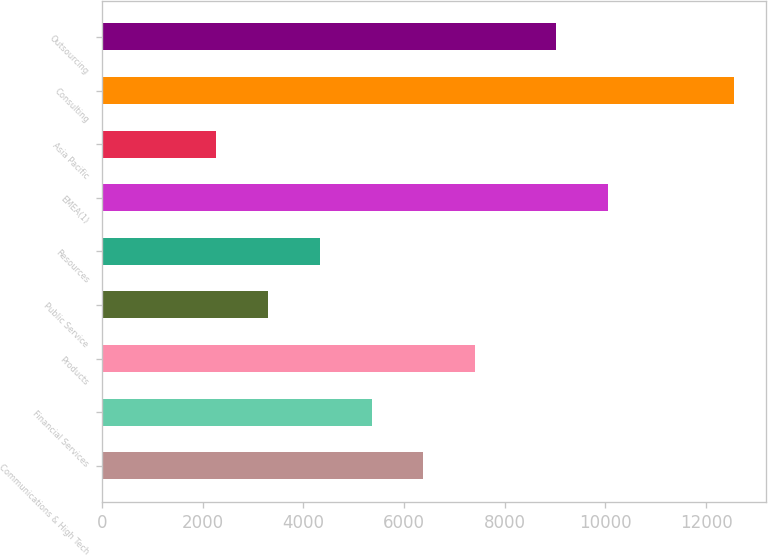Convert chart. <chart><loc_0><loc_0><loc_500><loc_500><bar_chart><fcel>Communications & High Tech<fcel>Financial Services<fcel>Products<fcel>Public Service<fcel>Resources<fcel>EMEA(1)<fcel>Asia Pacific<fcel>Consulting<fcel>Outsourcing<nl><fcel>6384.4<fcel>5355.8<fcel>7413<fcel>3298.6<fcel>4327.2<fcel>10049.6<fcel>2270<fcel>12556<fcel>9021<nl></chart> 